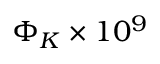Convert formula to latex. <formula><loc_0><loc_0><loc_500><loc_500>\Phi _ { K } \times 1 0 ^ { 9 }</formula> 